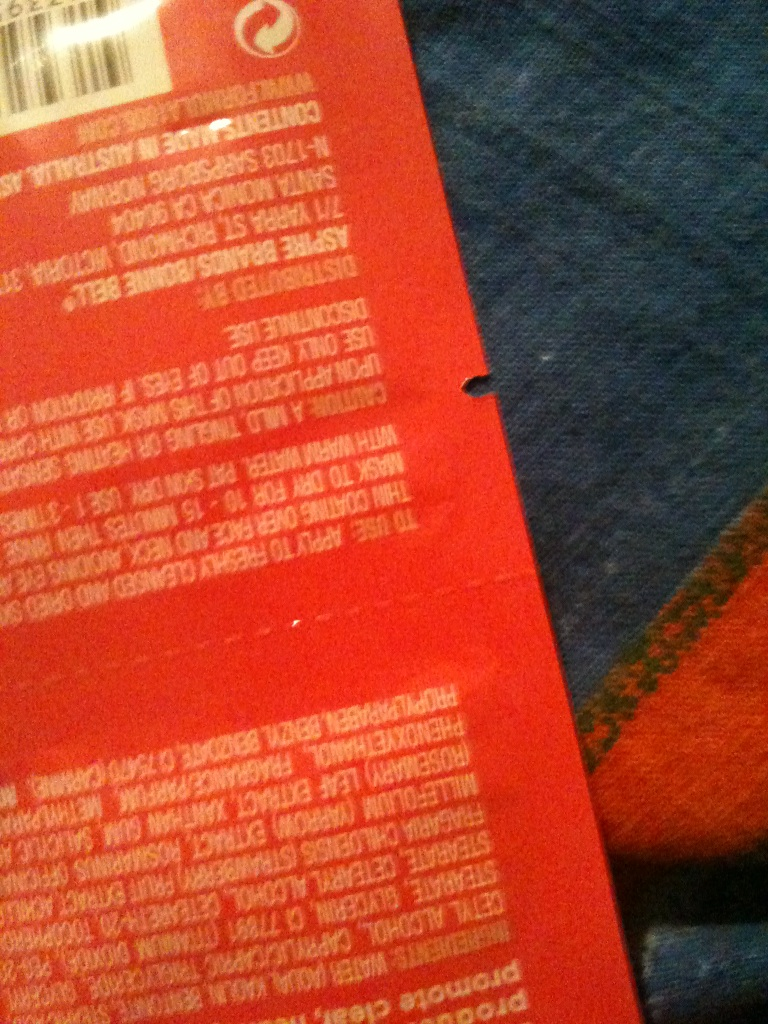Can you help me identify any text on the packaging that could indicate what this product is? The image is blurry, but I can make out some words which appear to be related to hair care, suggesting that it could potentially be a hair care product such as shampoo or conditioner.  What colors can you see on the package that might give us a clue about the product? The packaging is predominantly red with white text. Red is a common color for various personal care products, and it can sometimes be associated with products that aim to add vibrancy or protect colored hair. 